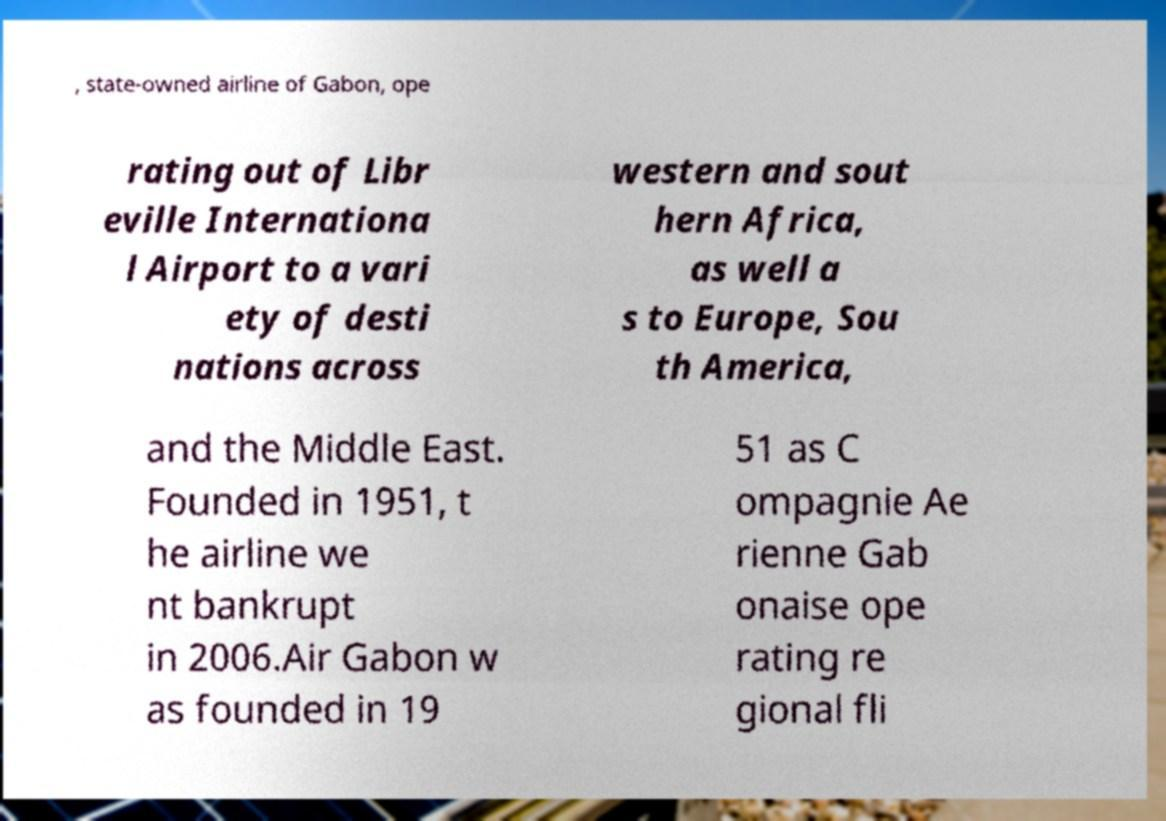For documentation purposes, I need the text within this image transcribed. Could you provide that? , state-owned airline of Gabon, ope rating out of Libr eville Internationa l Airport to a vari ety of desti nations across western and sout hern Africa, as well a s to Europe, Sou th America, and the Middle East. Founded in 1951, t he airline we nt bankrupt in 2006.Air Gabon w as founded in 19 51 as C ompagnie Ae rienne Gab onaise ope rating re gional fli 